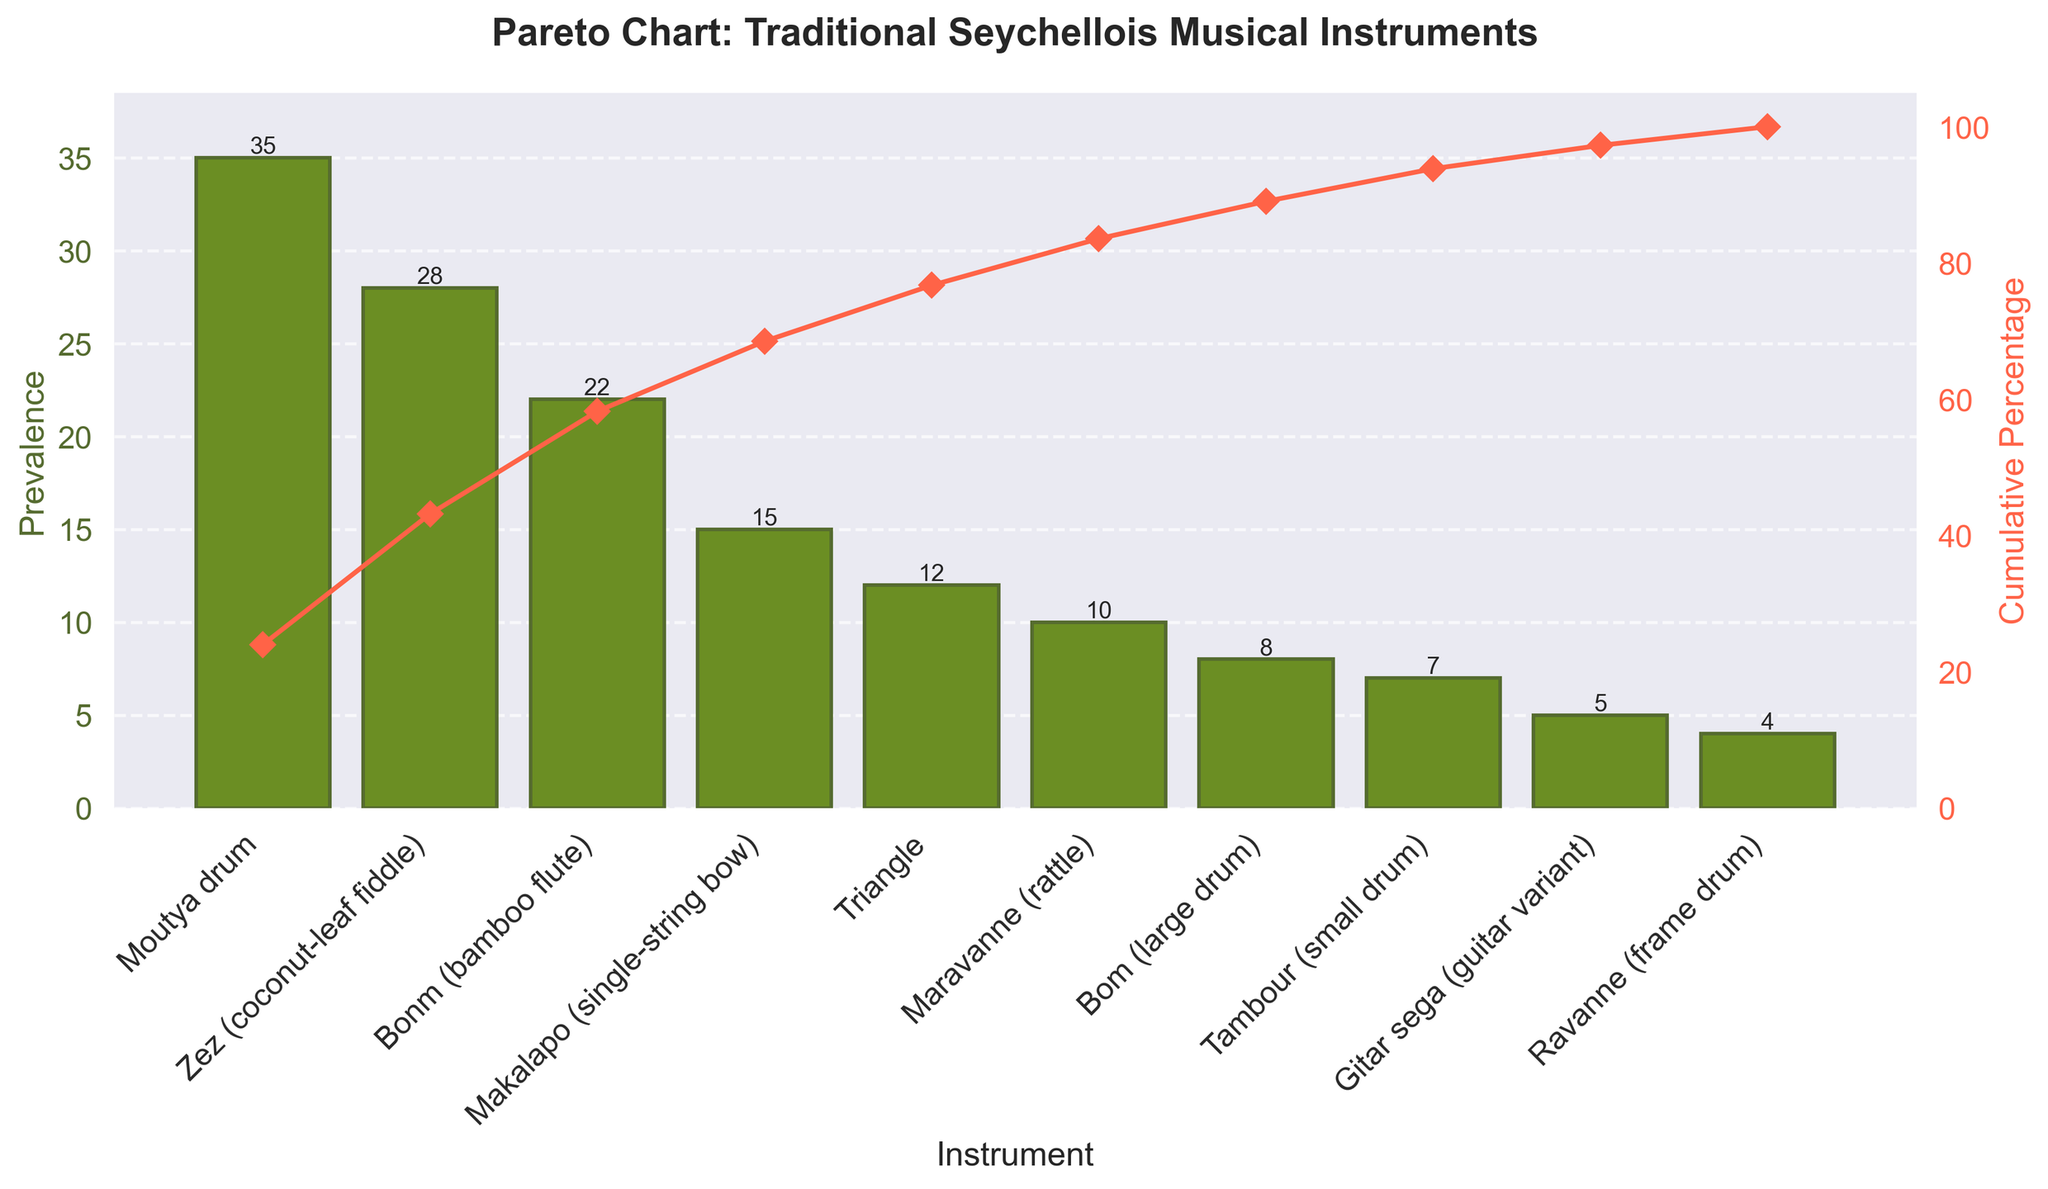what is the most prevalent instrument? The most prevalent instrument is identified by the tallest bar in the chart. The "Moutya drum" has the top position with the highest bar.
Answer: Moutya drum Which instrument has the least prevalence? The least prevalent instrument is identified by the shortest bar in the chart. The "Ravanne (frame drum)" has the lowest bar.
Answer: Ravanne (frame drum) How many instruments have a prevalence of 10 or less? Count the bars that have their heights at 10 or below. The instruments with prevalence of 10 or less are "Maravanne (rattle), Bom (large drum), Tambour (small drum), Gitar sega (guitar variant), and Ravanne (frame drum)".
Answer: 5 What is the cumulative percentage at the "Zez (coconut-leaf fiddle)" Find the mark on the line plot at the "Zez (coconut-leaf fiddle)", which corresponds to the cumulative percentage. The cumulative percentage is 63% at "Zez".
Answer: 63% Which instrument is higher in prevalence: "Bonm (bamboo flute)" or "Makalapo (single-string bow)"? Compare the heights of the bars for "Bonm" and "Makalapo". The bar for "Bonm (bamboo flute)" is higher than that for "Makalapo (single-string bow)".
Answer: Bonm (bamboo flute) What is the cumulative percentage after the "Maravanne (rattle)"? Identify the cumulative percentage mark on the line plot just above "Maravanne (rattle)". It is 88%.
Answer: 88% What is the combined prevalence of "Moutya drum" and "Zez (coconut-leaf fiddle)"? Add the individual prevalences of "Moutya drum" (35) and "Zez" (28). 35 + 28 = 63.
Answer: 63 What is the difference in prevalence between the "Triangle" and the "Bonm (bamboo flute)"? Subtract the prevalence of "Bonm (22)" from that of "Triangle (12)". 22 - 12 = 10.
Answer: 10 Which instrument significantly boosts the cumulative percentage past 50%? Identify the bar after which the cumulative percentage surpasses 50%. The "Zez (coconut-leaf fiddle)" takes the cumulative percentage from 35% to 63%, thus past 50%.
Answer: Zez (coconut-leaf fiddle) Between "Bonm (bamboo flute)" and "Triangle", which contributes more to the cumulative percentage? Compare the heights of bars "Bonm (bamboo flute)" (22) and "Triangle" (12). "Bonm (bamboo flute)" has a higher prevalence and therefore contributes more to the cumulative percentage.
Answer: Bonm (bamboo flute) 